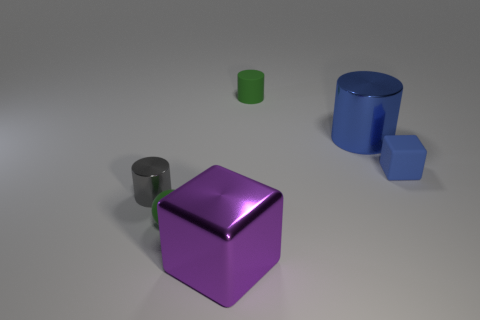Is the material of the small gray object the same as the tiny green cylinder?
Make the answer very short. No. The green thing behind the block that is behind the tiny rubber sphere is what shape?
Your response must be concise. Cylinder. There is a green matte thing that is behind the matte cube; what number of blue blocks are behind it?
Your answer should be very brief. 0. There is a tiny thing that is both in front of the blue cylinder and right of the small green sphere; what is its material?
Offer a terse response. Rubber. There is a blue matte object that is the same size as the matte cylinder; what shape is it?
Make the answer very short. Cube. There is a large thing behind the tiny green rubber object in front of the tiny blue matte cube that is in front of the large blue metallic cylinder; what is its color?
Make the answer very short. Blue. How many objects are either blue objects left of the tiny rubber cube or tiny green rubber objects?
Make the answer very short. 3. There is a green object that is the same size as the rubber ball; what material is it?
Your answer should be very brief. Rubber. What material is the tiny green thing that is to the right of the cube that is in front of the small cylinder in front of the big blue thing?
Offer a terse response. Rubber. What is the color of the tiny metal thing?
Offer a very short reply. Gray. 